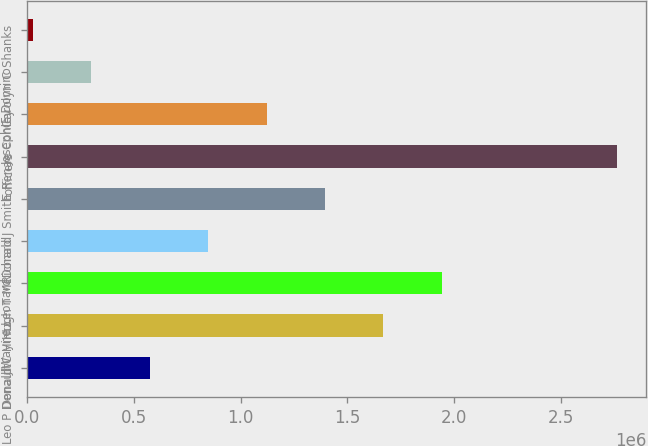Convert chart. <chart><loc_0><loc_0><loc_500><loc_500><bar_chart><fcel>Leo P Denault<fcel>Donald C Hintz<fcel>J Wayne Leonard<fcel>Hugh T McDonald<fcel>Richard J Smith<fcel>officers<fcel>E Renae Conley<fcel>Joseph F Domino<fcel>Carolyn C Shanks<nl><fcel>575374<fcel>1.66746e+06<fcel>1.94048e+06<fcel>848395<fcel>1.39444e+06<fcel>2.75954e+06<fcel>1.12142e+06<fcel>302354<fcel>29333<nl></chart> 